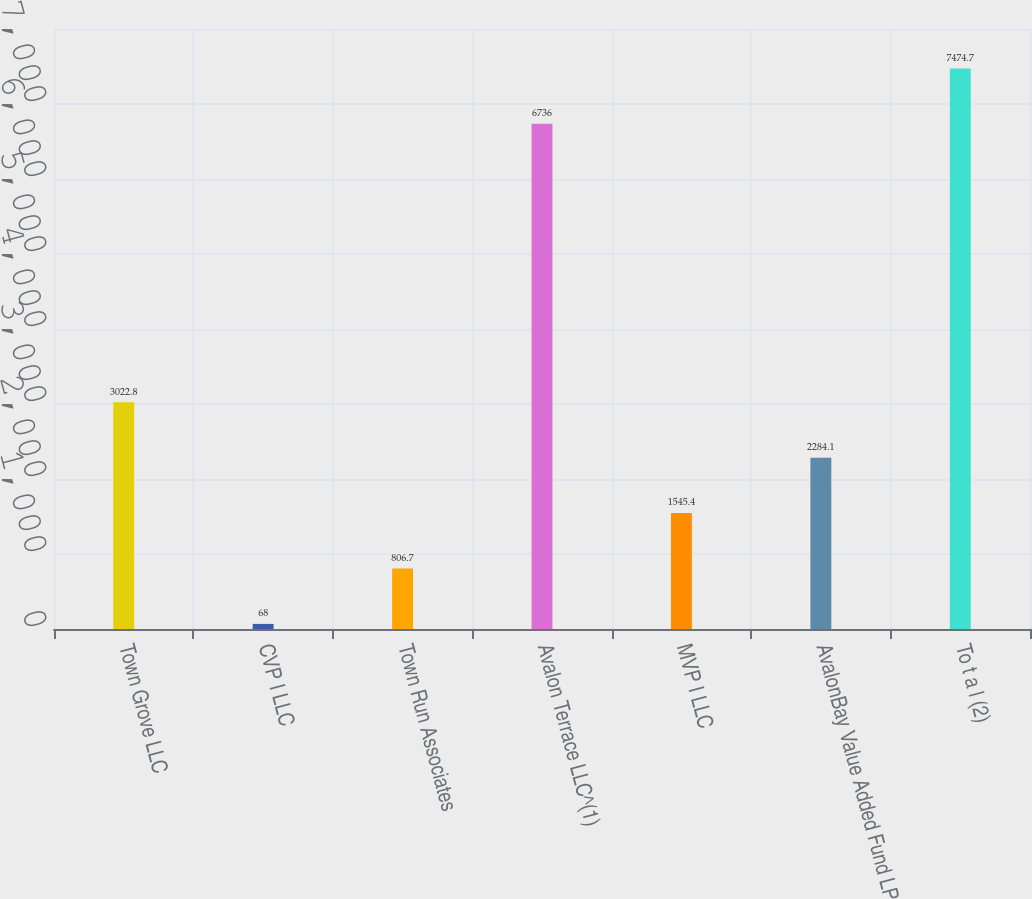Convert chart. <chart><loc_0><loc_0><loc_500><loc_500><bar_chart><fcel>Town Grove LLC<fcel>CVP I LLC<fcel>Town Run Associates<fcel>Avalon Terrace LLC^(1)<fcel>MVP I LLC<fcel>AvalonBay Value Added Fund LP<fcel>To t a l (2)<nl><fcel>3022.8<fcel>68<fcel>806.7<fcel>6736<fcel>1545.4<fcel>2284.1<fcel>7474.7<nl></chart> 